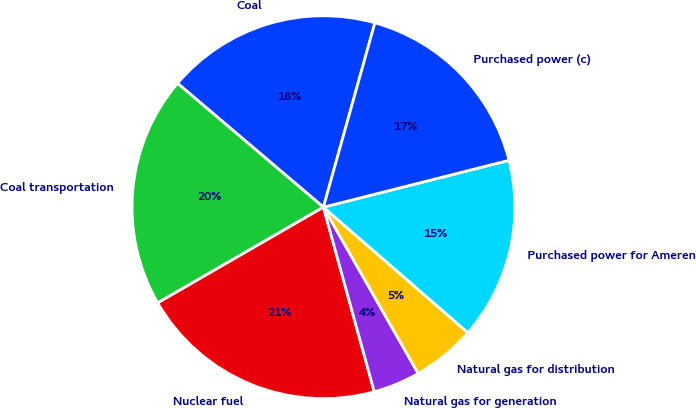Convert chart to OTSL. <chart><loc_0><loc_0><loc_500><loc_500><pie_chart><fcel>Coal<fcel>Coal transportation<fcel>Nuclear fuel<fcel>Natural gas for generation<fcel>Natural gas for distribution<fcel>Purchased power for Ameren<fcel>Purchased power (c)<nl><fcel>18.13%<fcel>19.54%<fcel>20.94%<fcel>3.97%<fcel>5.37%<fcel>15.32%<fcel>16.73%<nl></chart> 